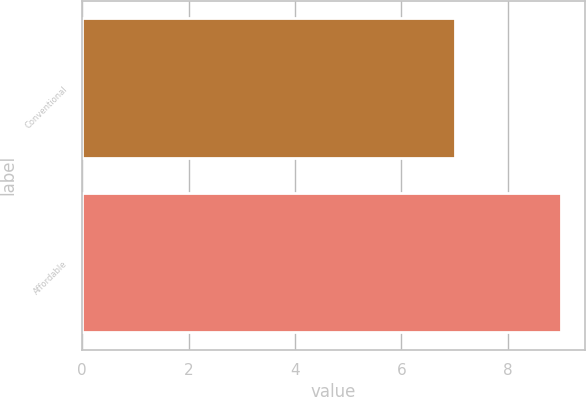Convert chart to OTSL. <chart><loc_0><loc_0><loc_500><loc_500><bar_chart><fcel>Conventional<fcel>Affordable<nl><fcel>7<fcel>9<nl></chart> 